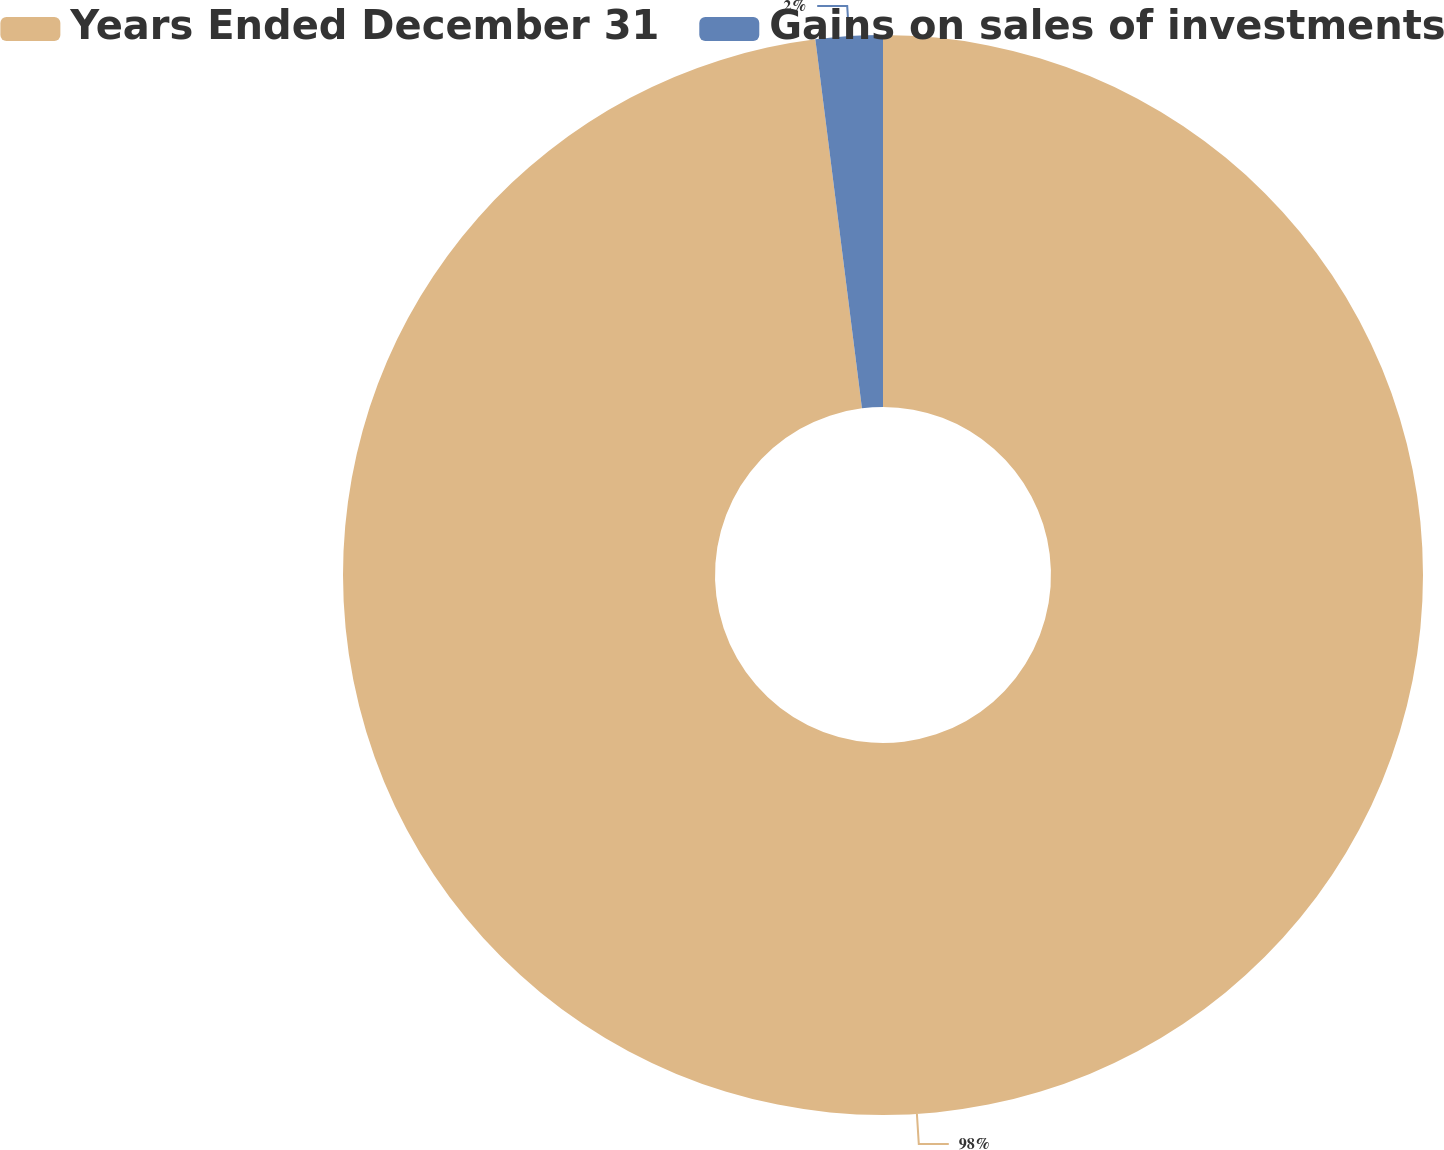Convert chart to OTSL. <chart><loc_0><loc_0><loc_500><loc_500><pie_chart><fcel>Years Ended December 31<fcel>Gains on sales of investments<nl><fcel>98.0%<fcel>2.0%<nl></chart> 